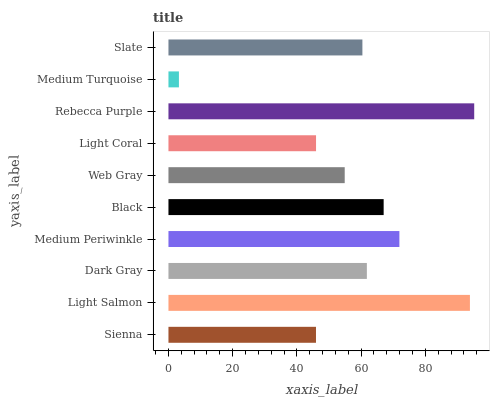Is Medium Turquoise the minimum?
Answer yes or no. Yes. Is Rebecca Purple the maximum?
Answer yes or no. Yes. Is Light Salmon the minimum?
Answer yes or no. No. Is Light Salmon the maximum?
Answer yes or no. No. Is Light Salmon greater than Sienna?
Answer yes or no. Yes. Is Sienna less than Light Salmon?
Answer yes or no. Yes. Is Sienna greater than Light Salmon?
Answer yes or no. No. Is Light Salmon less than Sienna?
Answer yes or no. No. Is Dark Gray the high median?
Answer yes or no. Yes. Is Slate the low median?
Answer yes or no. Yes. Is Light Coral the high median?
Answer yes or no. No. Is Light Coral the low median?
Answer yes or no. No. 